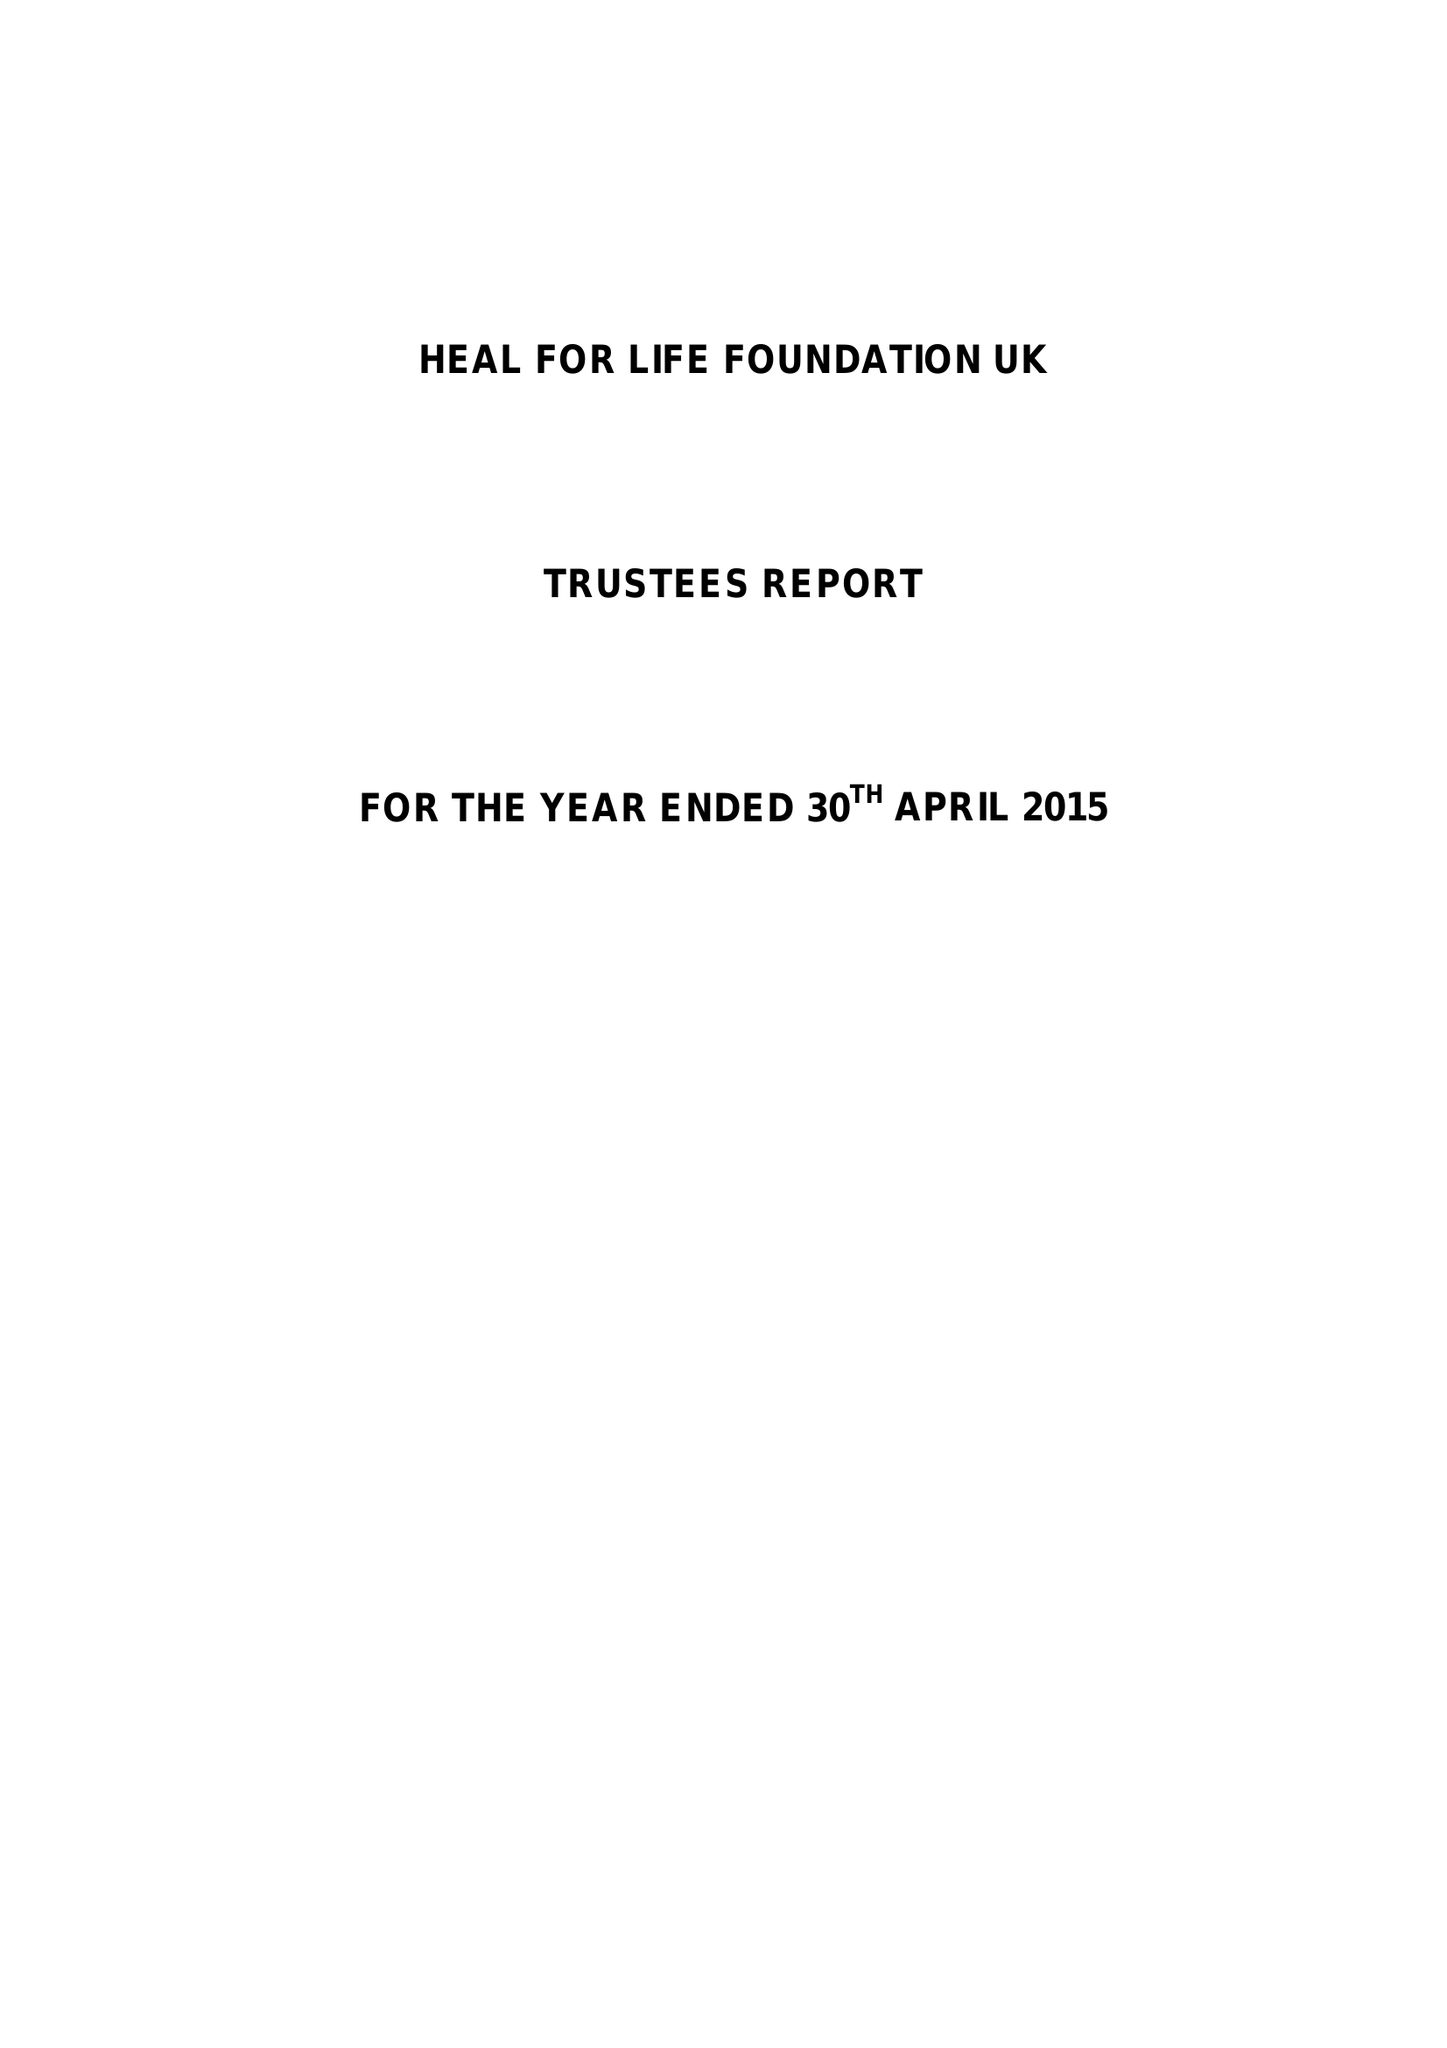What is the value for the charity_name?
Answer the question using a single word or phrase. Heal For Life Foundation Uk 